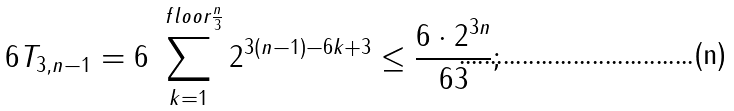<formula> <loc_0><loc_0><loc_500><loc_500>6 T _ { 3 , n - 1 } = 6 \sum _ { k = 1 } ^ { \ f l o o r { \frac { n } { 3 } } } 2 ^ { 3 ( n - 1 ) - 6 k + 3 } \leq \frac { 6 \cdot 2 ^ { 3 n } } { 6 3 } ;</formula> 